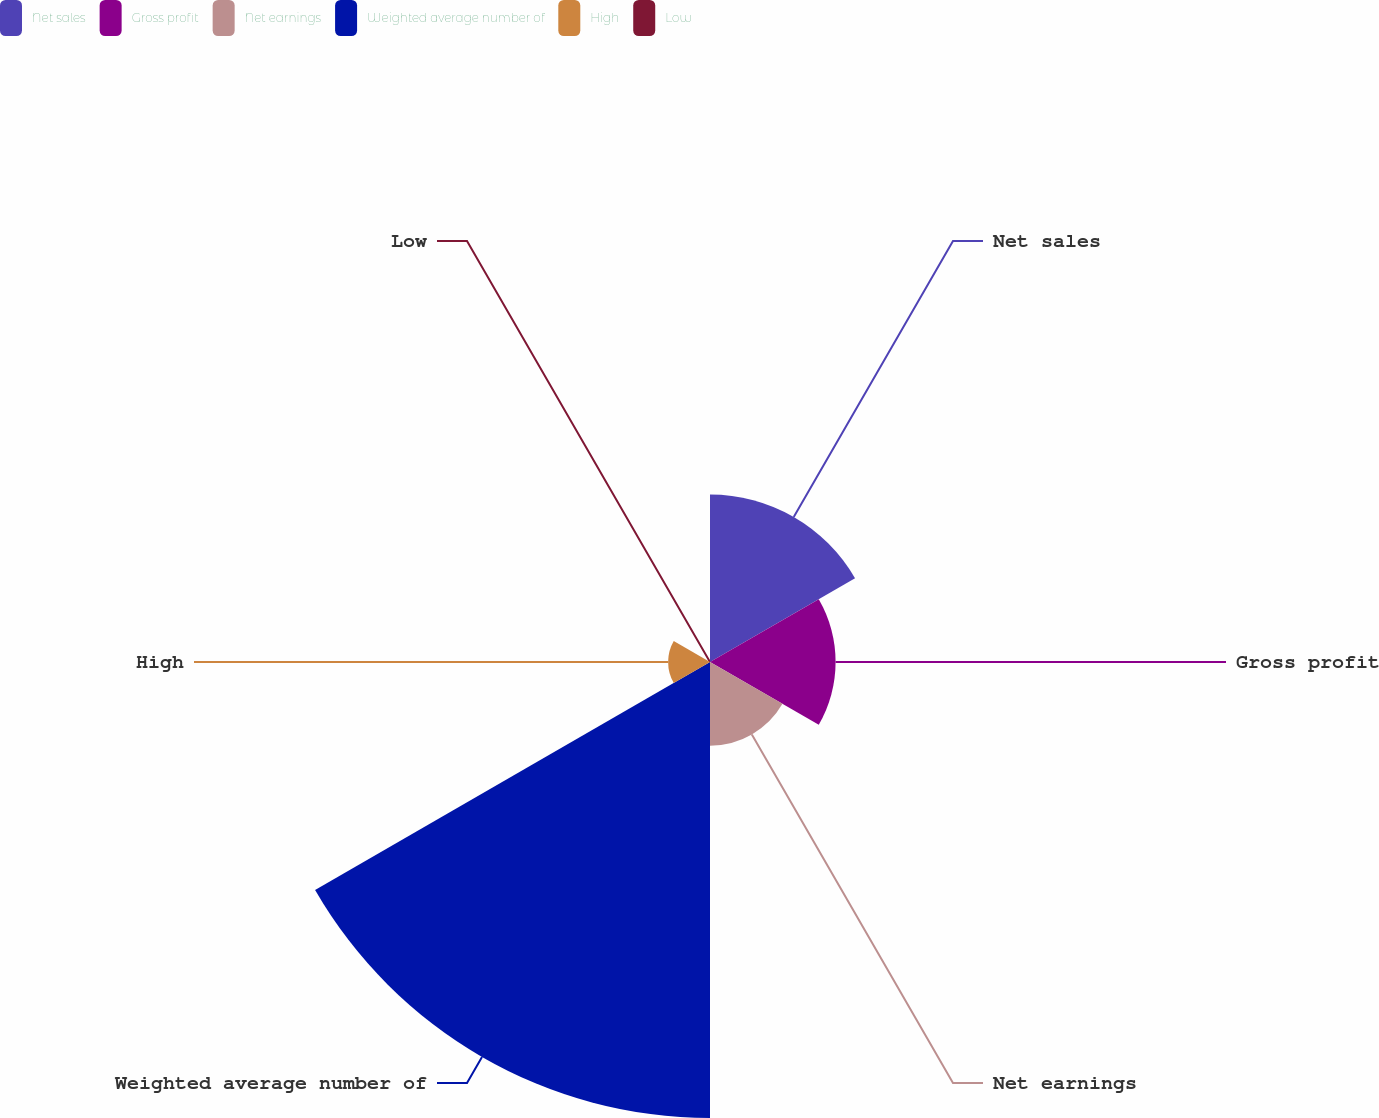Convert chart to OTSL. <chart><loc_0><loc_0><loc_500><loc_500><pie_chart><fcel>Net sales<fcel>Gross profit<fcel>Net earnings<fcel>Weighted average number of<fcel>High<fcel>Low<nl><fcel>19.15%<fcel>14.36%<fcel>9.57%<fcel>52.14%<fcel>4.79%<fcel>0.0%<nl></chart> 